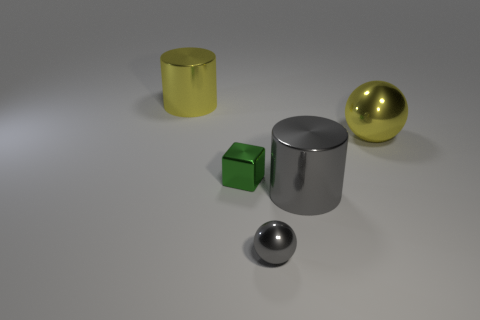Add 5 large yellow things. How many objects exist? 10 Subtract 1 gray cylinders. How many objects are left? 4 Subtract all cubes. How many objects are left? 4 Subtract 1 blocks. How many blocks are left? 0 Subtract all yellow spheres. Subtract all yellow cylinders. How many spheres are left? 1 Subtract all brown cubes. How many red spheres are left? 0 Subtract all large cylinders. Subtract all large metallic balls. How many objects are left? 2 Add 3 big yellow metallic objects. How many big yellow metallic objects are left? 5 Add 2 tiny gray objects. How many tiny gray objects exist? 3 